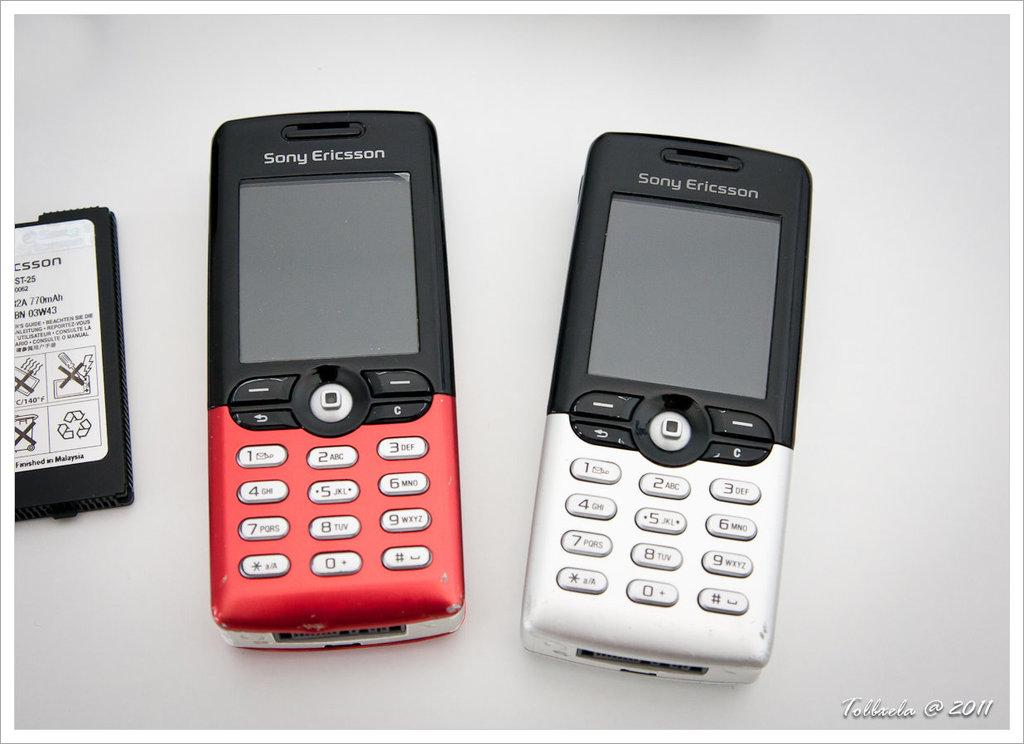<image>
Give a short and clear explanation of the subsequent image. a phone with the word Sony at the top of it 